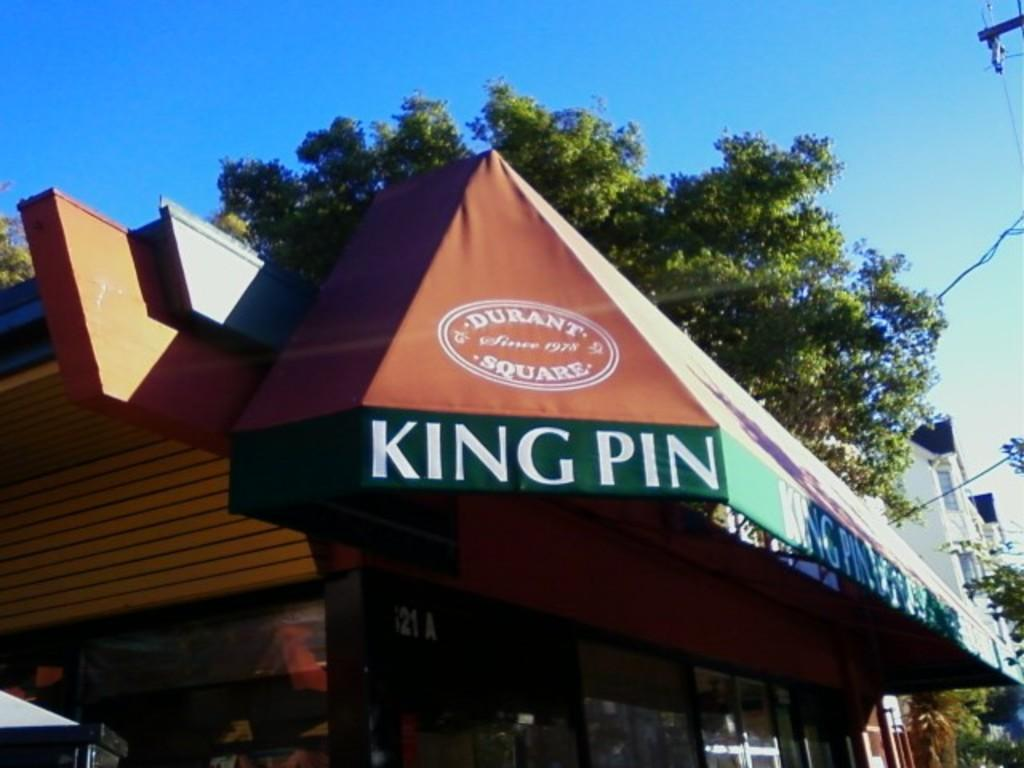What type of establishment is located in the middle of the image? There is a store in the middle of the image. What kind of vegetation is present in the image? There is a green tree in the image. What color is the sky in the image? The sky is blue in the image. What type of farm equipment can be seen in the image? There is no farm equipment present in the image. How does the tree produce its leaves in the image? The image does not show the process of the tree producing its leaves; it only shows the tree as it is. 